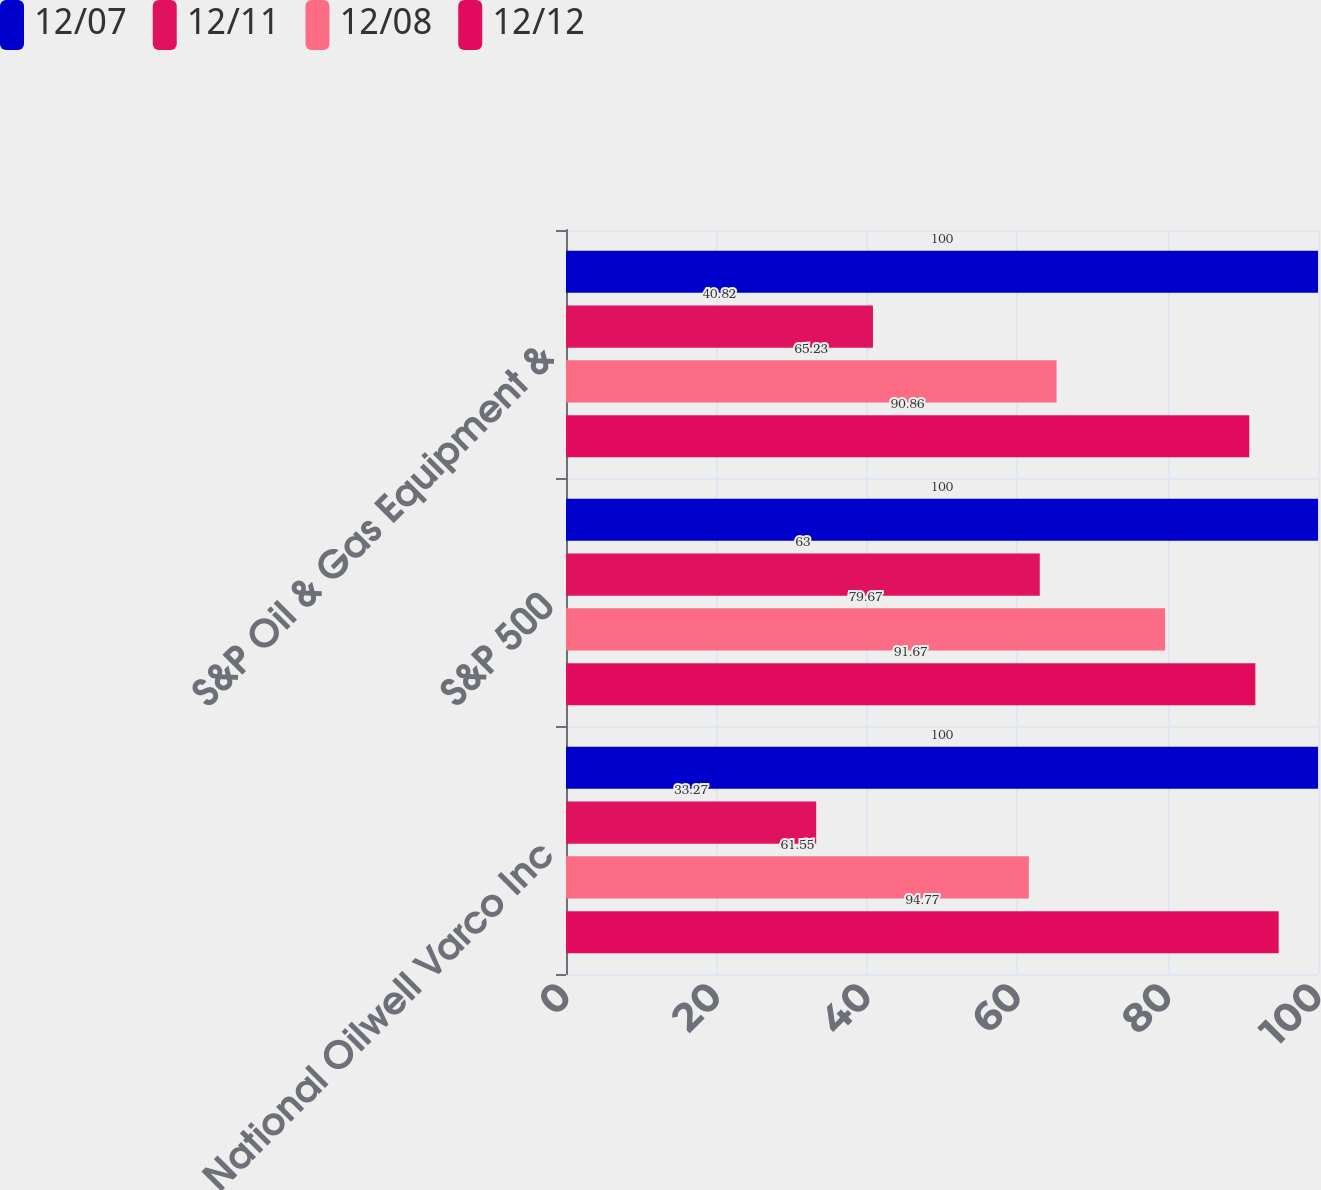<chart> <loc_0><loc_0><loc_500><loc_500><stacked_bar_chart><ecel><fcel>National Oilwell Varco Inc<fcel>S&P 500<fcel>S&P Oil & Gas Equipment &<nl><fcel>12/07<fcel>100<fcel>100<fcel>100<nl><fcel>12/11<fcel>33.27<fcel>63<fcel>40.82<nl><fcel>12/08<fcel>61.55<fcel>79.67<fcel>65.23<nl><fcel>12/12<fcel>94.77<fcel>91.67<fcel>90.86<nl></chart> 